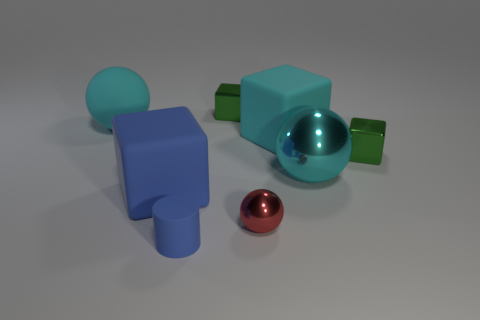There is a tiny blue thing that is made of the same material as the large cyan block; what shape is it?
Ensure brevity in your answer.  Cylinder. Is there any other thing of the same color as the small sphere?
Ensure brevity in your answer.  No. How many metal blocks are there?
Your response must be concise. 2. What shape is the tiny thing that is in front of the large blue rubber cube and to the left of the red shiny thing?
Provide a short and direct response. Cylinder. There is a big blue rubber object in front of the green metal cube that is behind the rubber cube that is right of the large blue rubber block; what shape is it?
Offer a terse response. Cube. There is a cyan thing that is behind the cyan shiny thing and to the right of the tiny red ball; what material is it?
Give a very brief answer. Rubber. What number of cubes have the same size as the red shiny ball?
Your response must be concise. 2. How many metal things are cylinders or large cyan spheres?
Keep it short and to the point. 1. What is the material of the small red thing?
Ensure brevity in your answer.  Metal. There is a small blue rubber cylinder; what number of large blue blocks are behind it?
Your response must be concise. 1. 